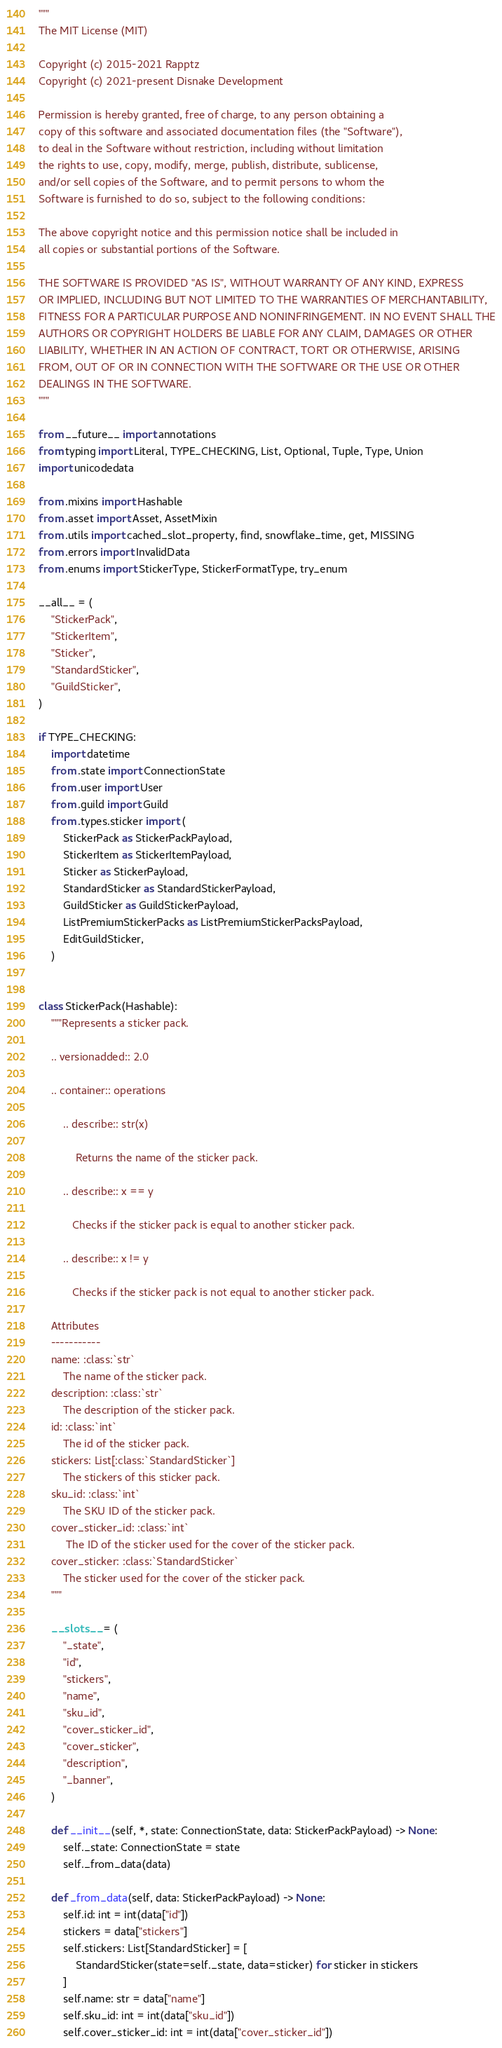Convert code to text. <code><loc_0><loc_0><loc_500><loc_500><_Python_>"""
The MIT License (MIT)

Copyright (c) 2015-2021 Rapptz
Copyright (c) 2021-present Disnake Development

Permission is hereby granted, free of charge, to any person obtaining a
copy of this software and associated documentation files (the "Software"),
to deal in the Software without restriction, including without limitation
the rights to use, copy, modify, merge, publish, distribute, sublicense,
and/or sell copies of the Software, and to permit persons to whom the
Software is furnished to do so, subject to the following conditions:

The above copyright notice and this permission notice shall be included in
all copies or substantial portions of the Software.

THE SOFTWARE IS PROVIDED "AS IS", WITHOUT WARRANTY OF ANY KIND, EXPRESS
OR IMPLIED, INCLUDING BUT NOT LIMITED TO THE WARRANTIES OF MERCHANTABILITY,
FITNESS FOR A PARTICULAR PURPOSE AND NONINFRINGEMENT. IN NO EVENT SHALL THE
AUTHORS OR COPYRIGHT HOLDERS BE LIABLE FOR ANY CLAIM, DAMAGES OR OTHER
LIABILITY, WHETHER IN AN ACTION OF CONTRACT, TORT OR OTHERWISE, ARISING
FROM, OUT OF OR IN CONNECTION WITH THE SOFTWARE OR THE USE OR OTHER
DEALINGS IN THE SOFTWARE.
"""

from __future__ import annotations
from typing import Literal, TYPE_CHECKING, List, Optional, Tuple, Type, Union
import unicodedata

from .mixins import Hashable
from .asset import Asset, AssetMixin
from .utils import cached_slot_property, find, snowflake_time, get, MISSING
from .errors import InvalidData
from .enums import StickerType, StickerFormatType, try_enum

__all__ = (
    "StickerPack",
    "StickerItem",
    "Sticker",
    "StandardSticker",
    "GuildSticker",
)

if TYPE_CHECKING:
    import datetime
    from .state import ConnectionState
    from .user import User
    from .guild import Guild
    from .types.sticker import (
        StickerPack as StickerPackPayload,
        StickerItem as StickerItemPayload,
        Sticker as StickerPayload,
        StandardSticker as StandardStickerPayload,
        GuildSticker as GuildStickerPayload,
        ListPremiumStickerPacks as ListPremiumStickerPacksPayload,
        EditGuildSticker,
    )


class StickerPack(Hashable):
    """Represents a sticker pack.

    .. versionadded:: 2.0

    .. container:: operations

        .. describe:: str(x)

            Returns the name of the sticker pack.

        .. describe:: x == y

           Checks if the sticker pack is equal to another sticker pack.

        .. describe:: x != y

           Checks if the sticker pack is not equal to another sticker pack.

    Attributes
    -----------
    name: :class:`str`
        The name of the sticker pack.
    description: :class:`str`
        The description of the sticker pack.
    id: :class:`int`
        The id of the sticker pack.
    stickers: List[:class:`StandardSticker`]
        The stickers of this sticker pack.
    sku_id: :class:`int`
        The SKU ID of the sticker pack.
    cover_sticker_id: :class:`int`
         The ID of the sticker used for the cover of the sticker pack.
    cover_sticker: :class:`StandardSticker`
        The sticker used for the cover of the sticker pack.
    """

    __slots__ = (
        "_state",
        "id",
        "stickers",
        "name",
        "sku_id",
        "cover_sticker_id",
        "cover_sticker",
        "description",
        "_banner",
    )

    def __init__(self, *, state: ConnectionState, data: StickerPackPayload) -> None:
        self._state: ConnectionState = state
        self._from_data(data)

    def _from_data(self, data: StickerPackPayload) -> None:
        self.id: int = int(data["id"])
        stickers = data["stickers"]
        self.stickers: List[StandardSticker] = [
            StandardSticker(state=self._state, data=sticker) for sticker in stickers
        ]
        self.name: str = data["name"]
        self.sku_id: int = int(data["sku_id"])
        self.cover_sticker_id: int = int(data["cover_sticker_id"])</code> 